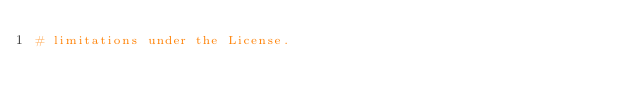Convert code to text. <code><loc_0><loc_0><loc_500><loc_500><_Python_># limitations under the License.

</code> 